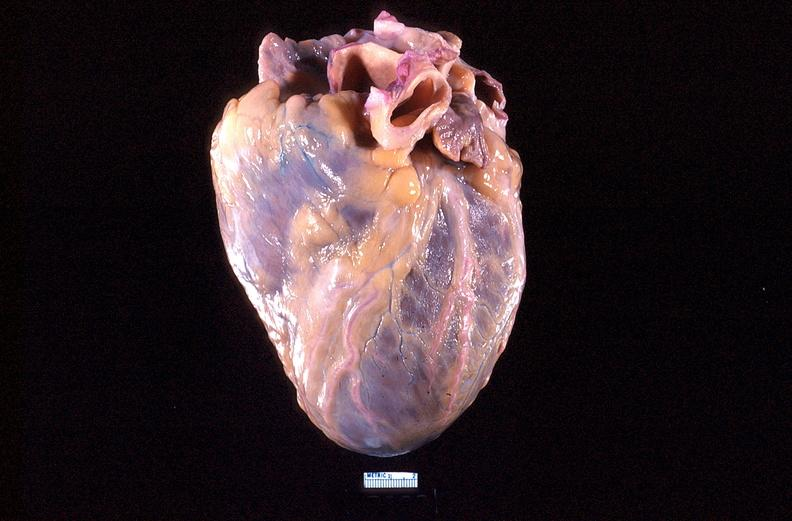does this image show heart, anterior surface, acute posterior myocardial infarction?
Answer the question using a single word or phrase. Yes 